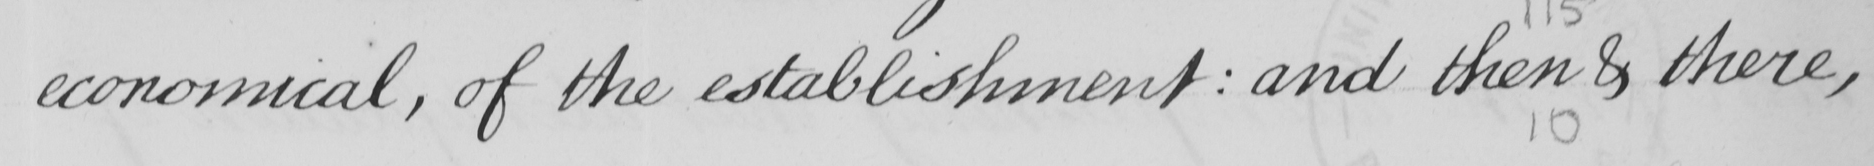Can you tell me what this handwritten text says? economical , of the establishment :  and then & there , 